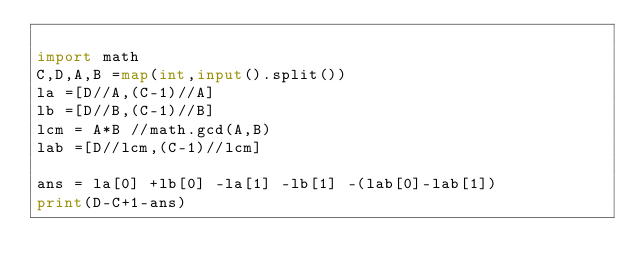<code> <loc_0><loc_0><loc_500><loc_500><_Python_>
import math
C,D,A,B =map(int,input().split())
la =[D//A,(C-1)//A]
lb =[D//B,(C-1)//B]
lcm = A*B //math.gcd(A,B)
lab =[D//lcm,(C-1)//lcm]

ans = la[0] +lb[0] -la[1] -lb[1] -(lab[0]-lab[1])
print(D-C+1-ans)</code> 